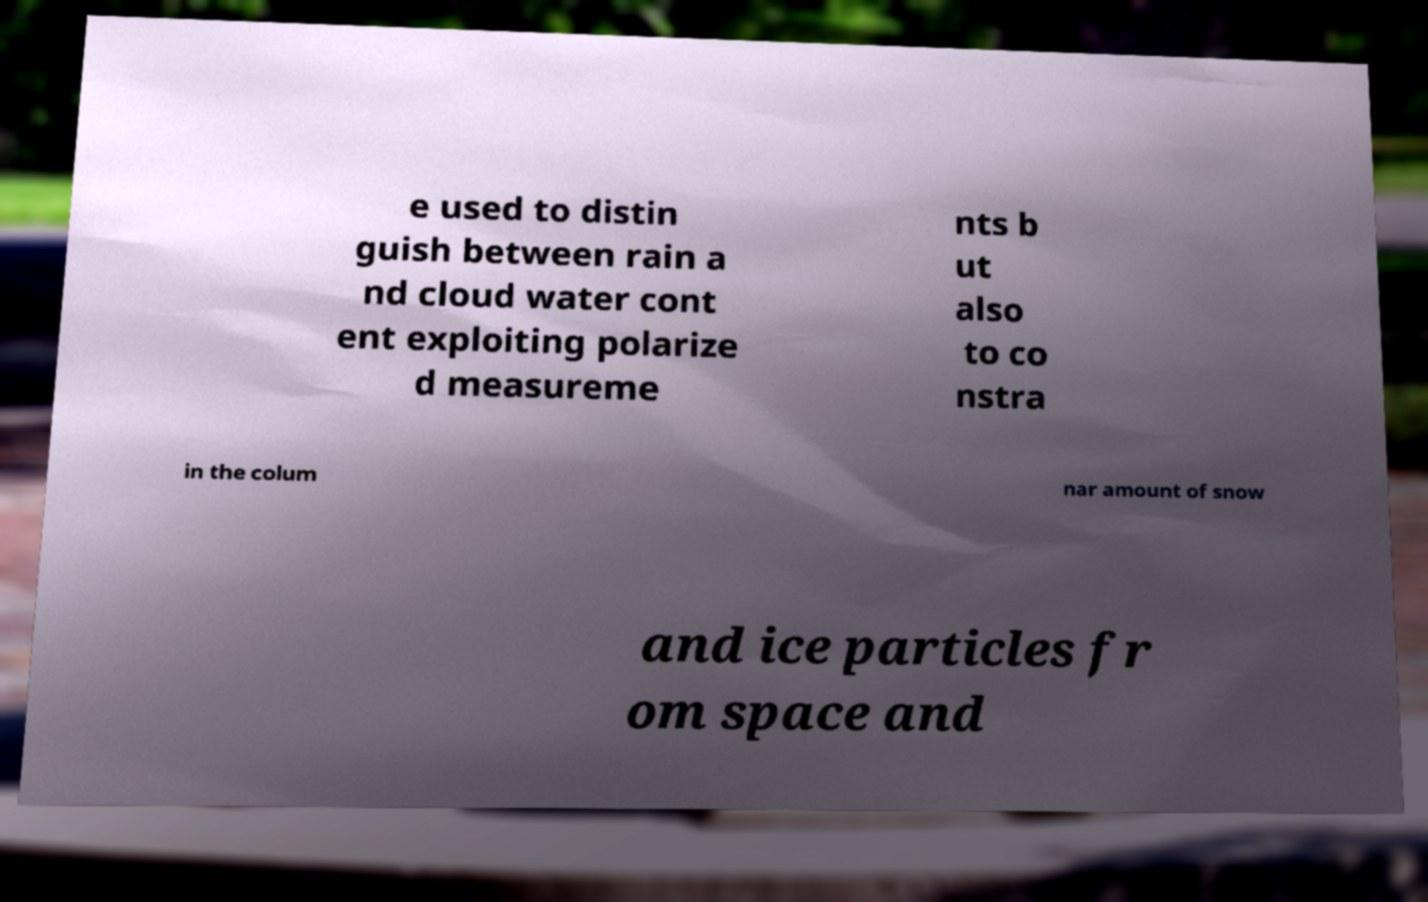Could you assist in decoding the text presented in this image and type it out clearly? e used to distin guish between rain a nd cloud water cont ent exploiting polarize d measureme nts b ut also to co nstra in the colum nar amount of snow and ice particles fr om space and 